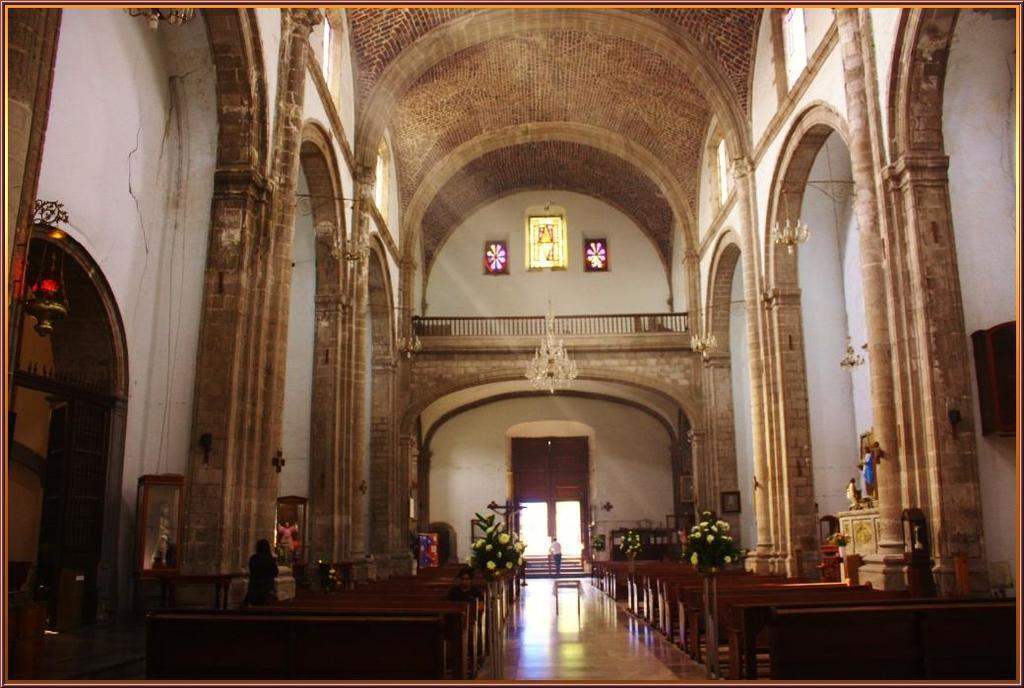What type of location is depicted in the image? The image is an inside view of a building. What decorative elements can be seen in the image? There are flower pots and statues in the image. What type of furniture is present in the image? There are benches in the image. Who or what is present in the image? There are people and statues in the image. What type of lighting is present in the image? There are ceiling lights in the image. What architectural features can be seen in the image? There are stands and a wall in the image. What is the floor like in the image? There is a floor in the image. How many houses are visible in the image? There are no houses visible in the image; it is an inside view of a building. What type of fingerprint can be seen on the statue in the image? There is no fingerprint present on the statue in the image. 